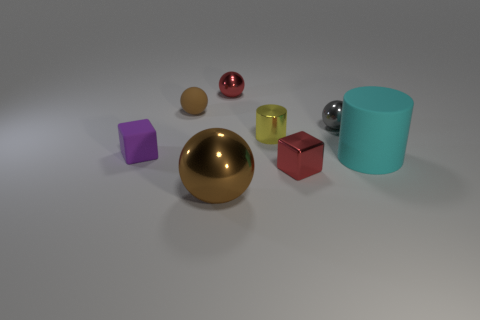Is there another large matte cylinder of the same color as the matte cylinder?
Your answer should be compact. No. Are there any other tiny metal things of the same shape as the purple thing?
Your response must be concise. Yes. What is the shape of the matte thing that is both left of the big cyan matte thing and in front of the brown rubber sphere?
Your response must be concise. Cube. What number of large brown balls are made of the same material as the tiny brown object?
Offer a terse response. 0. Are there fewer big cyan objects that are left of the small purple object than small purple rubber blocks?
Provide a succinct answer. Yes. Is there a tiny red object in front of the gray ball on the left side of the cyan matte object?
Offer a very short reply. Yes. Do the cyan object and the purple object have the same size?
Your answer should be very brief. No. What is the material of the block in front of the block left of the small block that is in front of the cyan matte thing?
Give a very brief answer. Metal. Are there an equal number of brown spheres to the right of the gray shiny ball and large purple cubes?
Make the answer very short. Yes. What number of objects are red things or gray balls?
Keep it short and to the point. 3. 